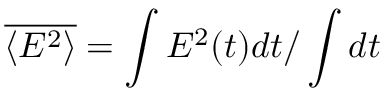Convert formula to latex. <formula><loc_0><loc_0><loc_500><loc_500>\overline { { \left \langle E ^ { 2 } \right \rangle } } = \int E ^ { 2 } ( t ) d t / \int d t</formula> 